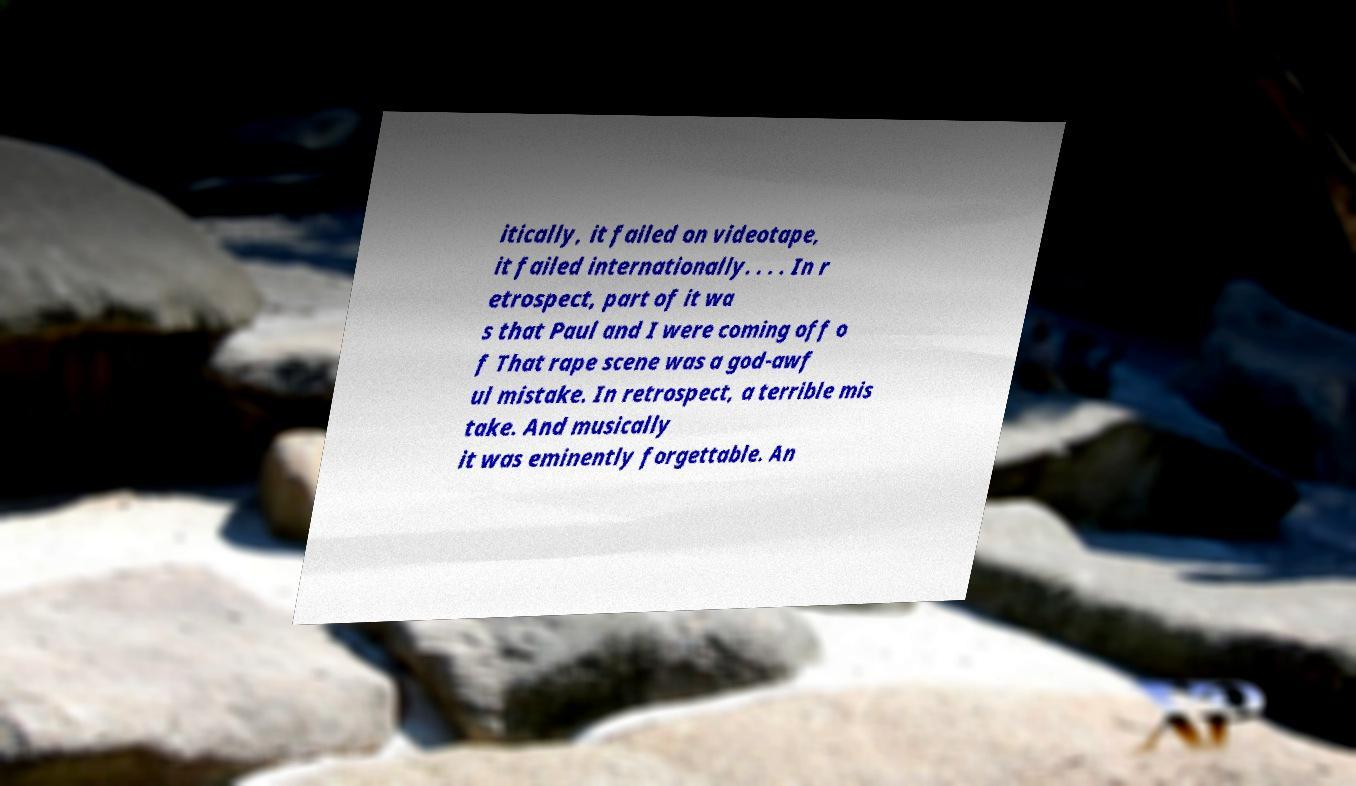Please read and relay the text visible in this image. What does it say? itically, it failed on videotape, it failed internationally. . . . In r etrospect, part of it wa s that Paul and I were coming off o f That rape scene was a god-awf ul mistake. In retrospect, a terrible mis take. And musically it was eminently forgettable. An 